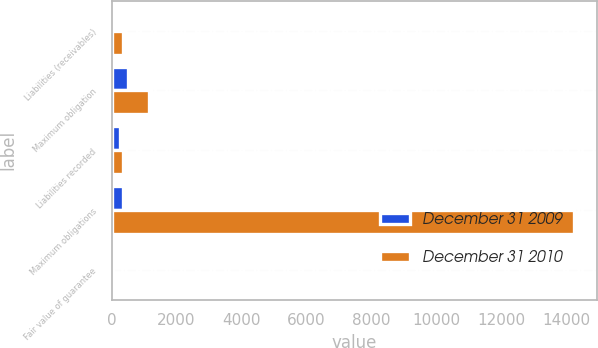<chart> <loc_0><loc_0><loc_500><loc_500><stacked_bar_chart><ecel><fcel>Liabilities (receivables)<fcel>Maximum obligation<fcel>Liabilities recorded<fcel>Maximum obligations<fcel>Fair value of guarantee<nl><fcel>December 31 2009<fcel>24<fcel>523<fcel>269<fcel>366<fcel>21<nl><fcel>December 31 2010<fcel>369<fcel>1159<fcel>366<fcel>14249<fcel>46<nl></chart> 